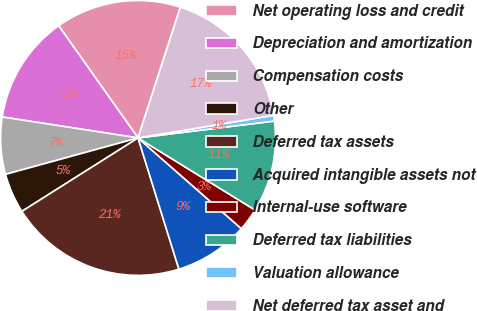Convert chart to OTSL. <chart><loc_0><loc_0><loc_500><loc_500><pie_chart><fcel>Net operating loss and credit<fcel>Depreciation and amortization<fcel>Compensation costs<fcel>Other<fcel>Deferred tax assets<fcel>Acquired intangible assets not<fcel>Internal-use software<fcel>Deferred tax liabilities<fcel>Valuation allowance<fcel>Net deferred tax asset and<nl><fcel>14.78%<fcel>12.76%<fcel>6.71%<fcel>4.7%<fcel>20.83%<fcel>8.73%<fcel>2.68%<fcel>10.75%<fcel>0.67%<fcel>17.39%<nl></chart> 